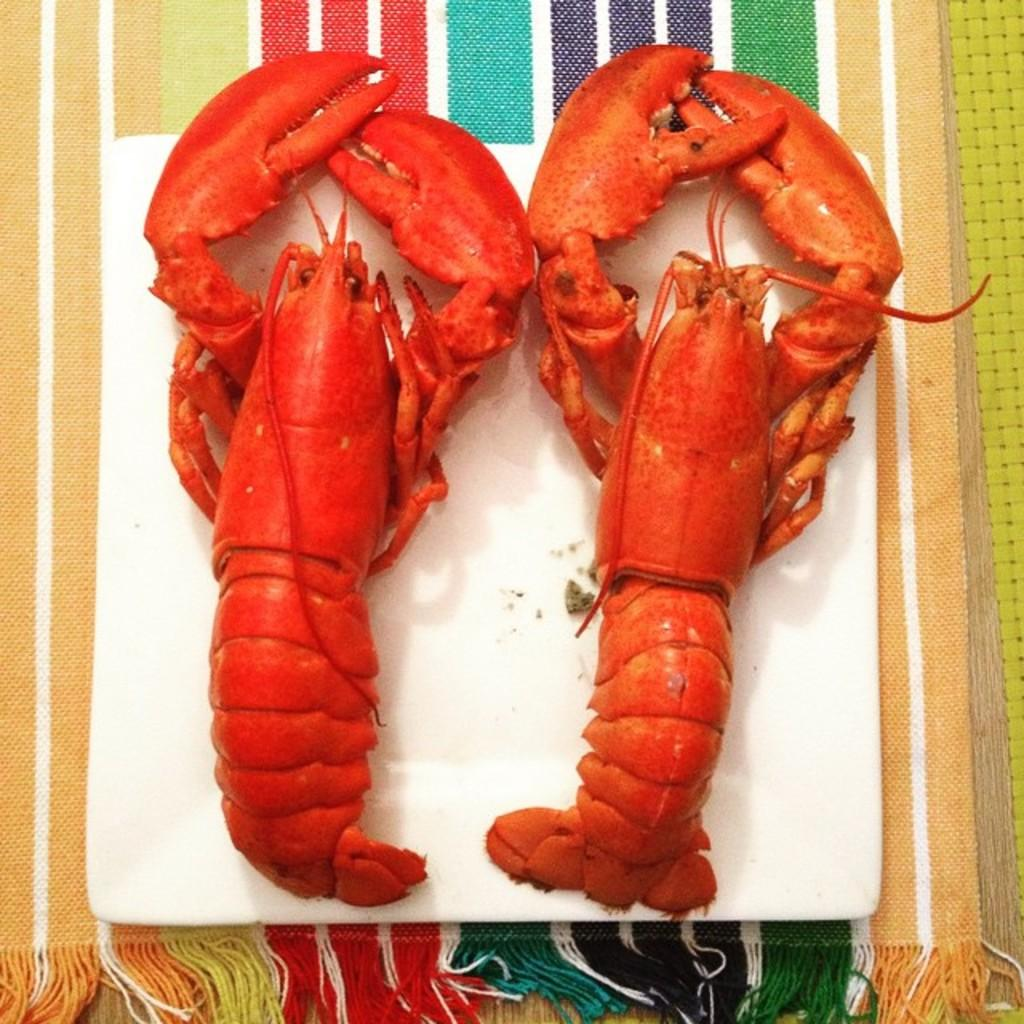What is on the plate in the image? There is a food item on a plate in the image. What can be seen on the surface that resembles a table? There is a cloth on the surface in the image. What shape is the rat in the image? There is no rat present in the image. How many sidewalks can be seen in the image? There are no sidewalks present in the image. 